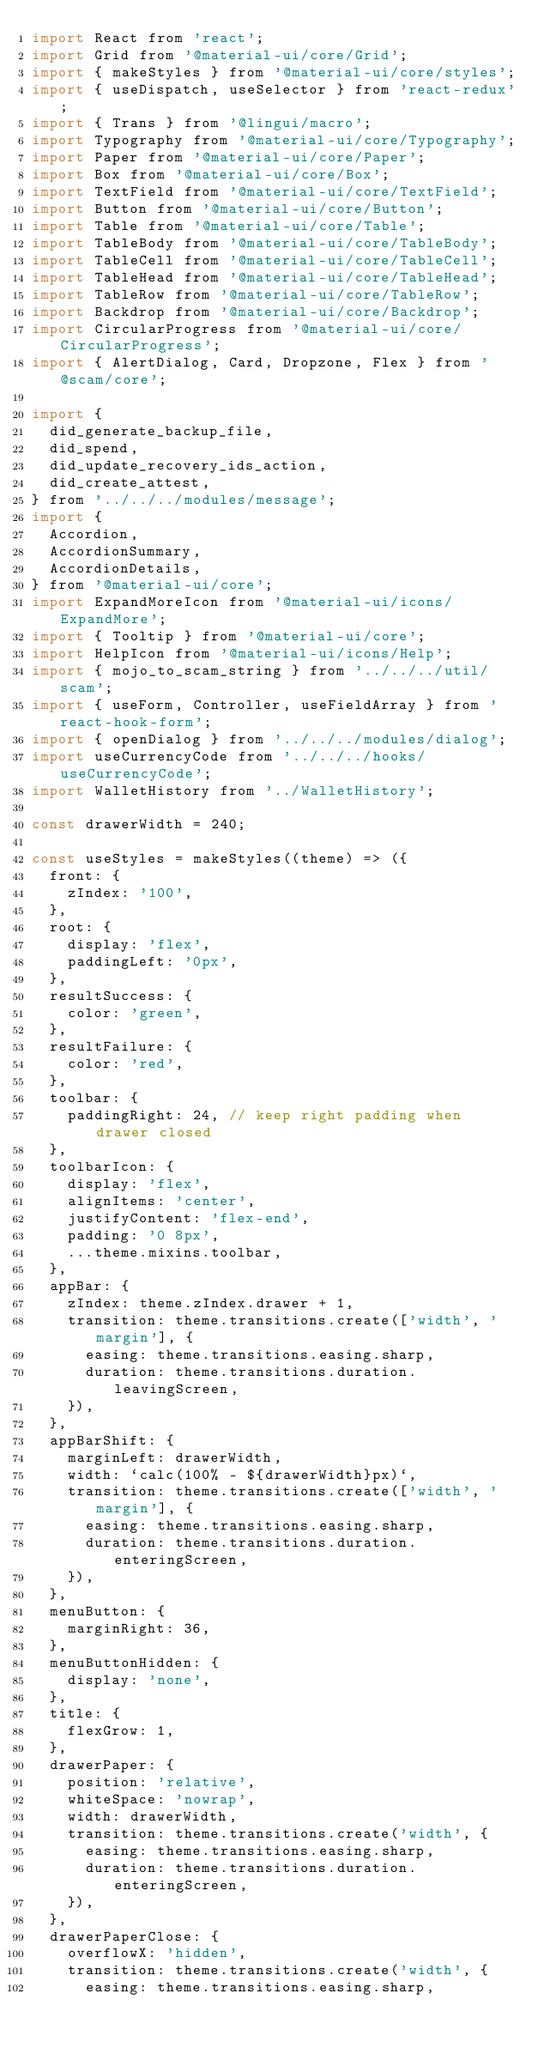<code> <loc_0><loc_0><loc_500><loc_500><_JavaScript_>import React from 'react';
import Grid from '@material-ui/core/Grid';
import { makeStyles } from '@material-ui/core/styles';
import { useDispatch, useSelector } from 'react-redux';
import { Trans } from '@lingui/macro';
import Typography from '@material-ui/core/Typography';
import Paper from '@material-ui/core/Paper';
import Box from '@material-ui/core/Box';
import TextField from '@material-ui/core/TextField';
import Button from '@material-ui/core/Button';
import Table from '@material-ui/core/Table';
import TableBody from '@material-ui/core/TableBody';
import TableCell from '@material-ui/core/TableCell';
import TableHead from '@material-ui/core/TableHead';
import TableRow from '@material-ui/core/TableRow';
import Backdrop from '@material-ui/core/Backdrop';
import CircularProgress from '@material-ui/core/CircularProgress';
import { AlertDialog, Card, Dropzone, Flex } from '@scam/core';

import {
  did_generate_backup_file,
  did_spend,
  did_update_recovery_ids_action,
  did_create_attest,
} from '../../../modules/message';
import {
  Accordion,
  AccordionSummary,
  AccordionDetails,
} from '@material-ui/core';
import ExpandMoreIcon from '@material-ui/icons/ExpandMore';
import { Tooltip } from '@material-ui/core';
import HelpIcon from '@material-ui/icons/Help';
import { mojo_to_scam_string } from '../../../util/scam';
import { useForm, Controller, useFieldArray } from 'react-hook-form';
import { openDialog } from '../../../modules/dialog';
import useCurrencyCode from '../../../hooks/useCurrencyCode';
import WalletHistory from '../WalletHistory';

const drawerWidth = 240;

const useStyles = makeStyles((theme) => ({
  front: {
    zIndex: '100',
  },
  root: {
    display: 'flex',
    paddingLeft: '0px',
  },
  resultSuccess: {
    color: 'green',
  },
  resultFailure: {
    color: 'red',
  },
  toolbar: {
    paddingRight: 24, // keep right padding when drawer closed
  },
  toolbarIcon: {
    display: 'flex',
    alignItems: 'center',
    justifyContent: 'flex-end',
    padding: '0 8px',
    ...theme.mixins.toolbar,
  },
  appBar: {
    zIndex: theme.zIndex.drawer + 1,
    transition: theme.transitions.create(['width', 'margin'], {
      easing: theme.transitions.easing.sharp,
      duration: theme.transitions.duration.leavingScreen,
    }),
  },
  appBarShift: {
    marginLeft: drawerWidth,
    width: `calc(100% - ${drawerWidth}px)`,
    transition: theme.transitions.create(['width', 'margin'], {
      easing: theme.transitions.easing.sharp,
      duration: theme.transitions.duration.enteringScreen,
    }),
  },
  menuButton: {
    marginRight: 36,
  },
  menuButtonHidden: {
    display: 'none',
  },
  title: {
    flexGrow: 1,
  },
  drawerPaper: {
    position: 'relative',
    whiteSpace: 'nowrap',
    width: drawerWidth,
    transition: theme.transitions.create('width', {
      easing: theme.transitions.easing.sharp,
      duration: theme.transitions.duration.enteringScreen,
    }),
  },
  drawerPaperClose: {
    overflowX: 'hidden',
    transition: theme.transitions.create('width', {
      easing: theme.transitions.easing.sharp,</code> 